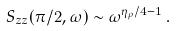Convert formula to latex. <formula><loc_0><loc_0><loc_500><loc_500>S _ { z z } ( \pi / 2 , \omega ) \sim \omega ^ { \eta _ { \rho } / 4 - 1 } \, .</formula> 